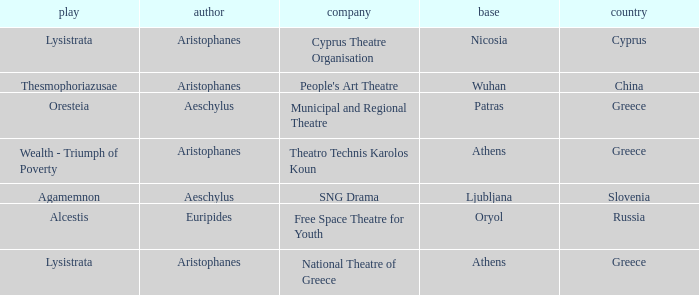What is the country when the base is ljubljana? Slovenia. 